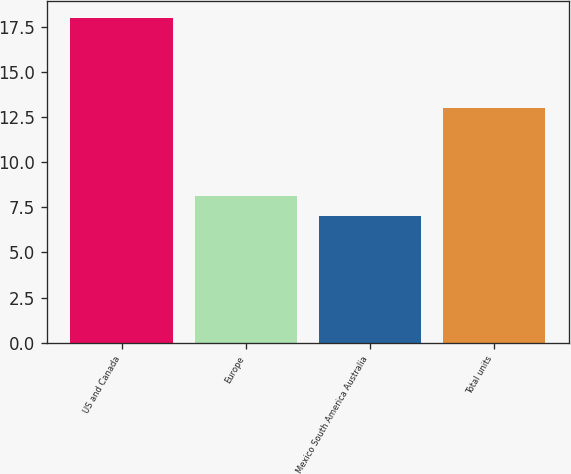Convert chart to OTSL. <chart><loc_0><loc_0><loc_500><loc_500><bar_chart><fcel>US and Canada<fcel>Europe<fcel>Mexico South America Australia<fcel>Total units<nl><fcel>18<fcel>8.1<fcel>7<fcel>13<nl></chart> 